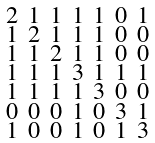Convert formula to latex. <formula><loc_0><loc_0><loc_500><loc_500>\begin{smallmatrix} 2 & 1 & 1 & 1 & 1 & 0 & 1 \\ 1 & 2 & 1 & 1 & 1 & 0 & 0 \\ 1 & 1 & 2 & 1 & 1 & 0 & 0 \\ 1 & 1 & 1 & 3 & 1 & 1 & 1 \\ 1 & 1 & 1 & 1 & 3 & 0 & 0 \\ 0 & 0 & 0 & 1 & 0 & 3 & 1 \\ 1 & 0 & 0 & 1 & 0 & 1 & 3 \end{smallmatrix}</formula> 